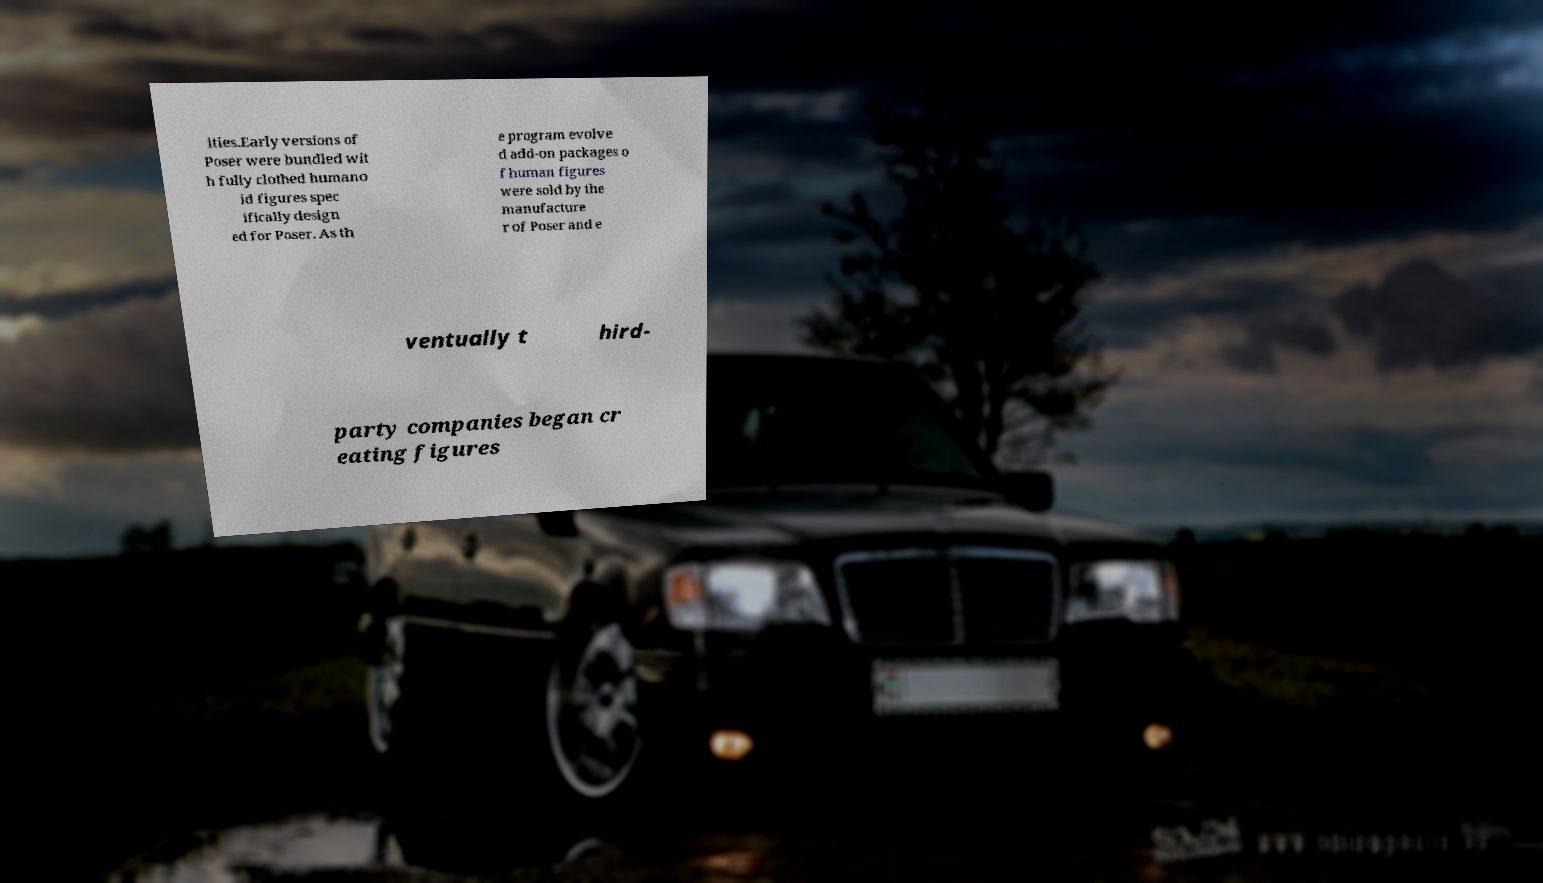I need the written content from this picture converted into text. Can you do that? ities.Early versions of Poser were bundled wit h fully clothed humano id figures spec ifically design ed for Poser. As th e program evolve d add-on packages o f human figures were sold by the manufacture r of Poser and e ventually t hird- party companies began cr eating figures 